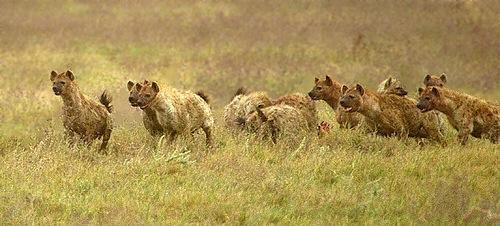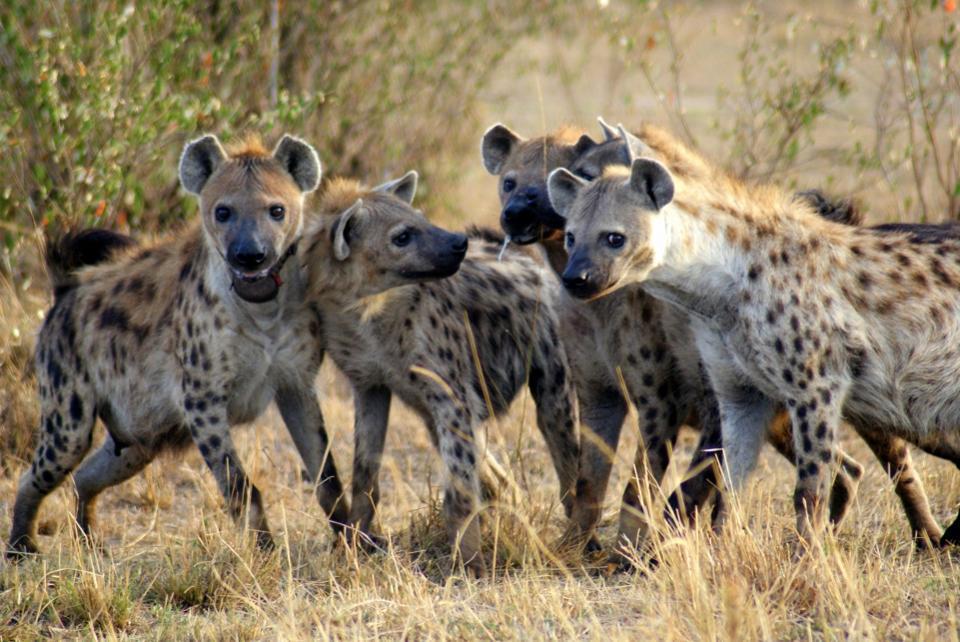The first image is the image on the left, the second image is the image on the right. Analyze the images presented: Is the assertion "One group of animals is standing in the water." valid? Answer yes or no. No. 